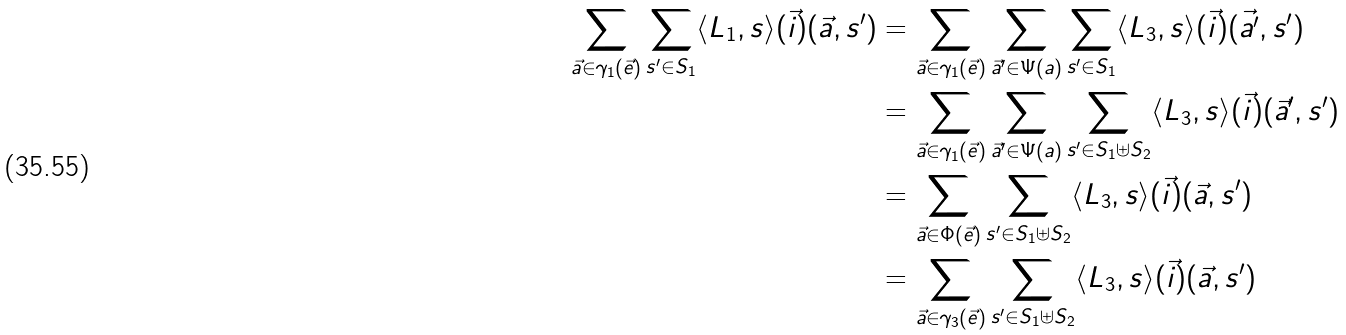<formula> <loc_0><loc_0><loc_500><loc_500>\sum _ { \vec { a } \in \gamma _ { 1 } ( \vec { e } ) } \sum _ { s ^ { \prime } \in S _ { 1 } } \langle L _ { 1 } , s \rangle ( \vec { i } ) ( \vec { a } , s ^ { \prime } ) & = \sum _ { \vec { a } \in \gamma _ { 1 } ( \vec { e } ) } \sum _ { \vec { a } ^ { \prime } \in \Psi ( a ) } \sum _ { s ^ { \prime } \in S _ { 1 } } \langle L _ { 3 } , s \rangle ( \vec { i } ) ( \vec { a ^ { \prime } } , s ^ { \prime } ) \\ & = \sum _ { \vec { a } \in \gamma _ { 1 } ( \vec { e } ) } \sum _ { \vec { a } ^ { \prime } \in \Psi ( a ) } \sum _ { s ^ { \prime } \in S _ { 1 } \uplus S _ { 2 } } \langle L _ { 3 } , s \rangle ( \vec { i } ) ( \vec { a } ^ { \prime } , s ^ { \prime } ) \\ & = \sum _ { \vec { a } \in \Phi ( \vec { e } ) } \sum _ { s ^ { \prime } \in S _ { 1 } \uplus S _ { 2 } } \langle L _ { 3 } , s \rangle ( \vec { i } ) ( \vec { a } , s ^ { \prime } ) \\ & = \sum _ { \vec { a } \in \gamma _ { 3 } ( \vec { e } ) } \sum _ { s ^ { \prime } \in S _ { 1 } \uplus S _ { 2 } } \langle L _ { 3 } , s \rangle ( \vec { i } ) ( \vec { a } , s ^ { \prime } )</formula> 